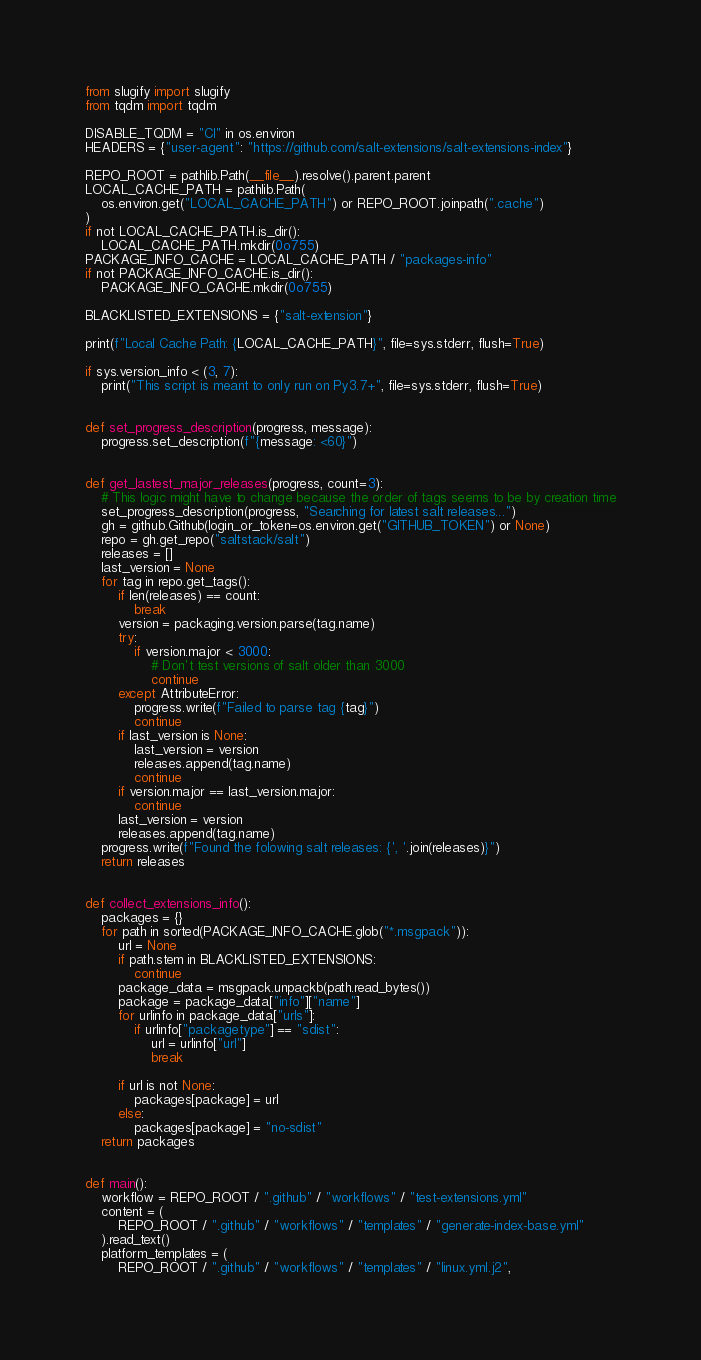<code> <loc_0><loc_0><loc_500><loc_500><_Python_>from slugify import slugify
from tqdm import tqdm

DISABLE_TQDM = "CI" in os.environ
HEADERS = {"user-agent": "https://github.com/salt-extensions/salt-extensions-index"}

REPO_ROOT = pathlib.Path(__file__).resolve().parent.parent
LOCAL_CACHE_PATH = pathlib.Path(
    os.environ.get("LOCAL_CACHE_PATH") or REPO_ROOT.joinpath(".cache")
)
if not LOCAL_CACHE_PATH.is_dir():
    LOCAL_CACHE_PATH.mkdir(0o755)
PACKAGE_INFO_CACHE = LOCAL_CACHE_PATH / "packages-info"
if not PACKAGE_INFO_CACHE.is_dir():
    PACKAGE_INFO_CACHE.mkdir(0o755)

BLACKLISTED_EXTENSIONS = {"salt-extension"}

print(f"Local Cache Path: {LOCAL_CACHE_PATH}", file=sys.stderr, flush=True)

if sys.version_info < (3, 7):
    print("This script is meant to only run on Py3.7+", file=sys.stderr, flush=True)


def set_progress_description(progress, message):
    progress.set_description(f"{message: <60}")


def get_lastest_major_releases(progress, count=3):
    # This logic might have to change because the order of tags seems to be by creation time
    set_progress_description(progress, "Searching for latest salt releases...")
    gh = github.Github(login_or_token=os.environ.get("GITHUB_TOKEN") or None)
    repo = gh.get_repo("saltstack/salt")
    releases = []
    last_version = None
    for tag in repo.get_tags():
        if len(releases) == count:
            break
        version = packaging.version.parse(tag.name)
        try:
            if version.major < 3000:
                # Don't test versions of salt older than 3000
                continue
        except AttributeError:
            progress.write(f"Failed to parse tag {tag}")
            continue
        if last_version is None:
            last_version = version
            releases.append(tag.name)
            continue
        if version.major == last_version.major:
            continue
        last_version = version
        releases.append(tag.name)
    progress.write(f"Found the folowing salt releases: {', '.join(releases)}")
    return releases


def collect_extensions_info():
    packages = {}
    for path in sorted(PACKAGE_INFO_CACHE.glob("*.msgpack")):
        url = None
        if path.stem in BLACKLISTED_EXTENSIONS:
            continue
        package_data = msgpack.unpackb(path.read_bytes())
        package = package_data["info"]["name"]
        for urlinfo in package_data["urls"]:
            if urlinfo["packagetype"] == "sdist":
                url = urlinfo["url"]
                break

        if url is not None:
            packages[package] = url
        else:
            packages[package] = "no-sdist"
    return packages


def main():
    workflow = REPO_ROOT / ".github" / "workflows" / "test-extensions.yml"
    content = (
        REPO_ROOT / ".github" / "workflows" / "templates" / "generate-index-base.yml"
    ).read_text()
    platform_templates = (
        REPO_ROOT / ".github" / "workflows" / "templates" / "linux.yml.j2",</code> 